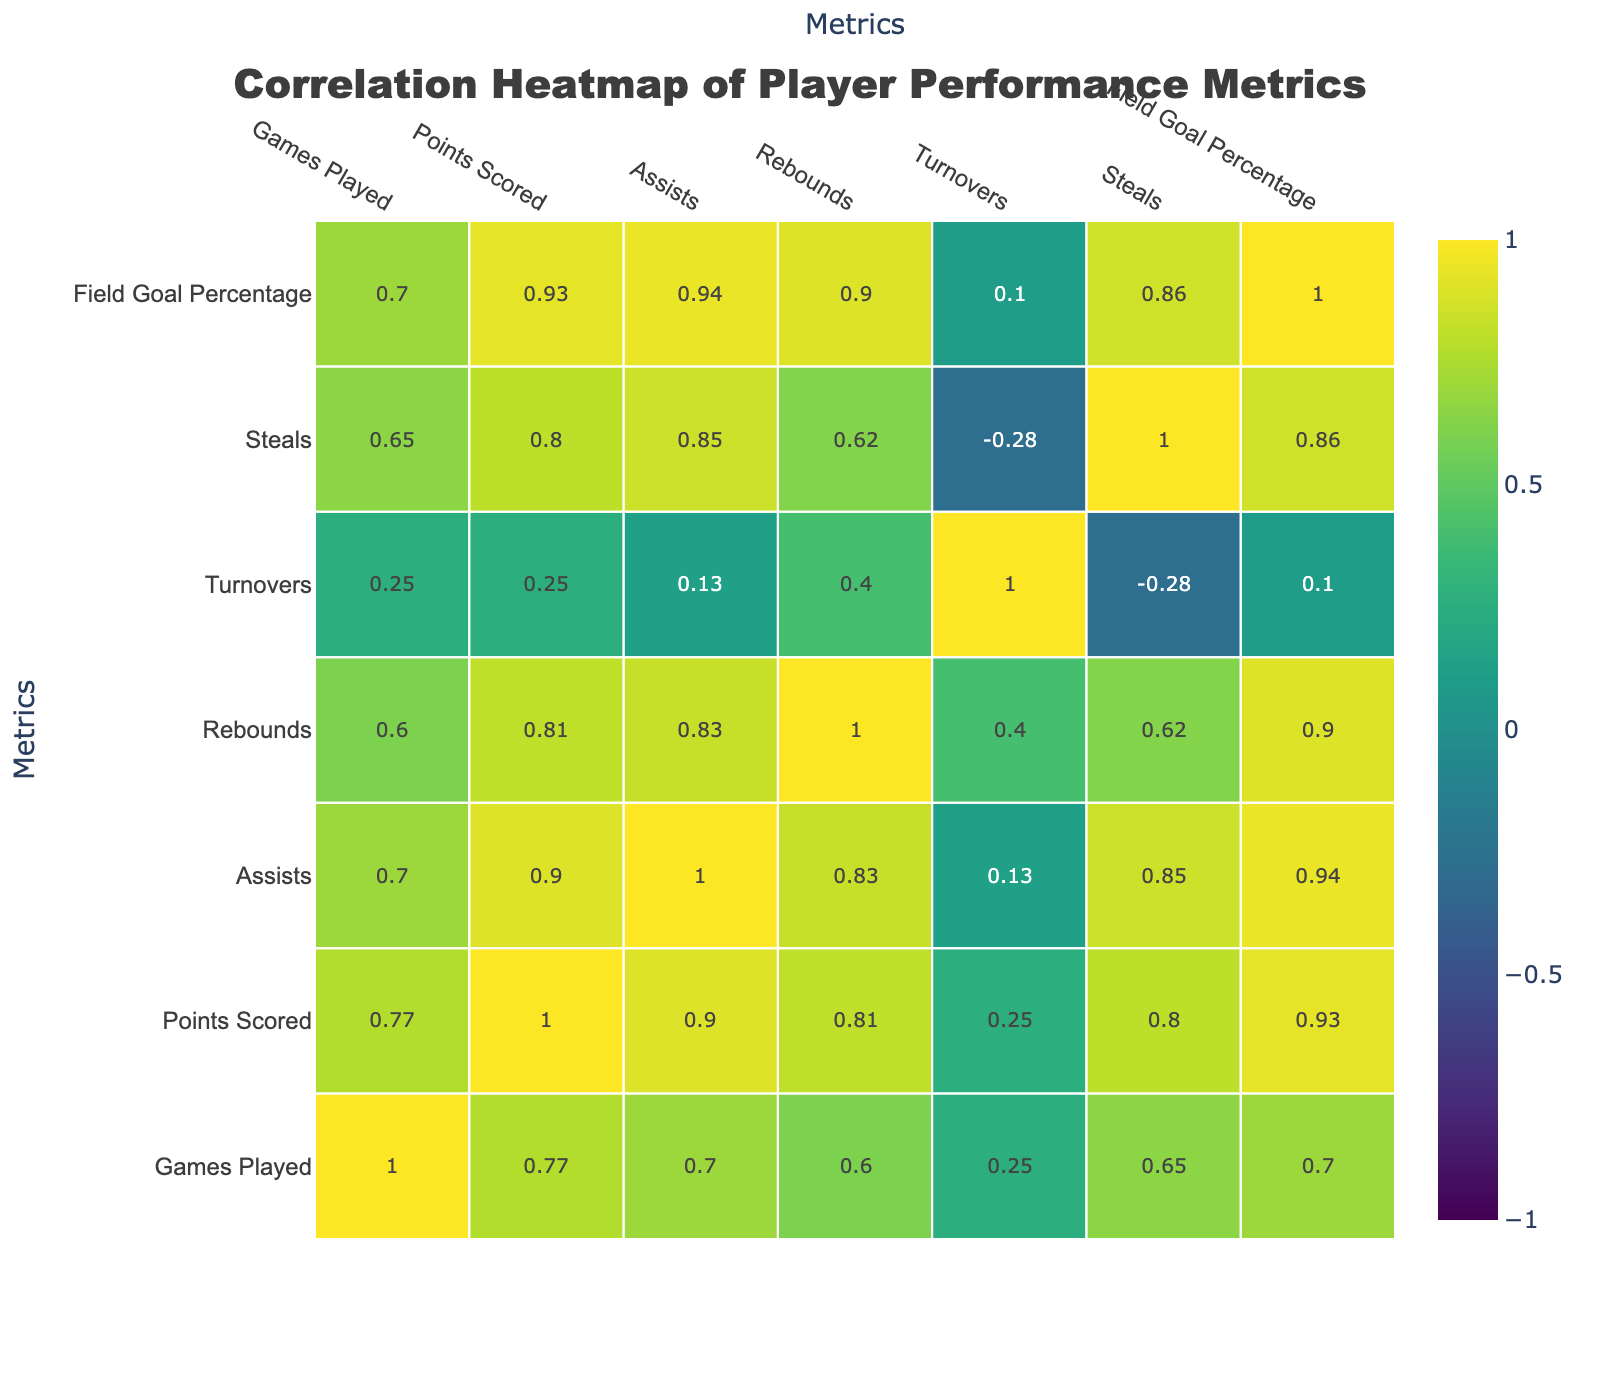What is the highest points scored by a player? By examining the "Points Scored" column, I can identify that James Carter has the highest points with a total of 400.
Answer: 400 Which player had the best field goal percentage? Reviewing the "Field Goal Percentage" column, James Carter scores the highest with 55.0%.
Answer: 55.0% What is the average number of assists for the players? I add together the total assists: (50 + 70 + 40 + 90 + 30 + 80 + 60 + 75 + 65 + 85) =  730. There are 10 players, so the average is 730/10 = 73.0.
Answer: 73.0 Did any player have more turnovers than assists? I compare each player's assists and turnovers. Kevin Brown had 30 turnovers and 30 assists, which is equal; David Lee had 25 turnovers and 40 assists, meaning no player had more turnovers than assists.
Answer: No What is the relationship between points scored and field goal percentage? I observe that the correlation between "Points Scored" and "Field Goal Percentage" is clearly positive, suggesting that players who score more points tend to have a higher field goal percentage.
Answer: Positive correlation What is the total number of games played by all players? I add up the games played: (15 + 20 + 18 + 22 + 16 + 19 + 14 + 21 + 17 + 20) =  192. Thus, the total number of games played is 192.
Answer: 192 Which player had the fewest rebounds? In the "Rebounds" column, I see Kevin Brown had the fewest rebounds with a total of 40.
Answer: 40 Is there a player with more steals than turnovers? I check each player's "Steals" versus "Turnovers." Eddie Chen, for instance, had 40 steals and 15 turnovers, confirming that there are players with more steals than turnovers.
Answer: Yes What is the difference in total points scored between the highest and lowest scorers? The highest points scored is 400 (James Carter), and the lowest is 180 (Kevin Brown). The difference is 400 - 180 = 220.
Answer: 220 